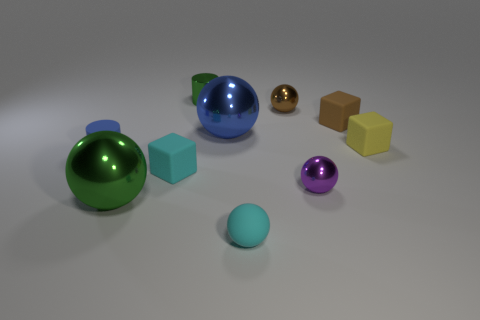There is a tiny cylinder that is behind the small yellow cube; what is its material?
Offer a terse response. Metal. How big is the green thing that is behind the tiny brown object on the right side of the brown shiny object?
Make the answer very short. Small. How many shiny cylinders have the same size as the purple metal thing?
Provide a short and direct response. 1. There is a tiny thing in front of the green metallic ball; does it have the same color as the cube that is on the left side of the tiny brown metal object?
Keep it short and to the point. Yes. Are there any tiny things in front of the cyan matte block?
Offer a very short reply. Yes. There is a tiny ball that is in front of the brown shiny sphere and behind the big green metal thing; what color is it?
Your response must be concise. Purple. Is there a object of the same color as the small rubber cylinder?
Ensure brevity in your answer.  Yes. Is the small cylinder that is on the left side of the green shiny ball made of the same material as the big sphere behind the tiny rubber cylinder?
Keep it short and to the point. No. How big is the metal ball in front of the purple object?
Your answer should be compact. Large. The cyan block is what size?
Your response must be concise. Small. 